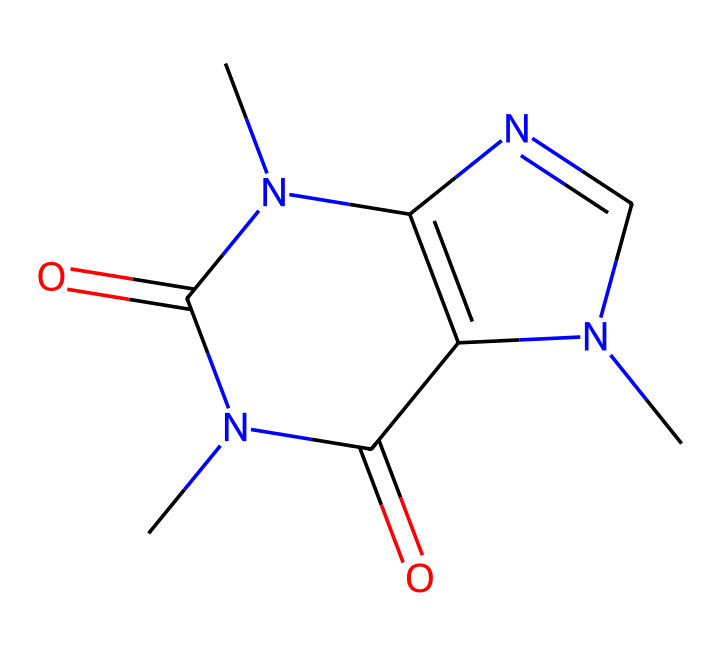What is the molecular formula of caffeine? To determine the molecular formula from the SMILES representation, we need to identify the components represented by the atoms. The SMILES shows carbon (C), nitrogen (N), and oxygen (O) atoms. Upon analyzing, we find there are 8 carbon atoms, 10 hydrogen atoms, 4 nitrogen atoms, and 2 oxygen atoms. Thus, the molecular formula derived is C8H10N4O2.
Answer: C8H10N4O2 How many nitrogen atoms are present in caffeine? By examining the SMILES notation, we can count the nitrogen atoms represented by the letter “N.” There are four occurrences of “N” in the structure. Therefore, there are four nitrogen atoms in caffeine.
Answer: 4 Is caffeine a heterocyclic compound? A heterocyclic compound contains a ring structure that includes at least one atom that is not carbon, commonly nitrogen, oxygen, or sulfur. The given SMILES indicates the presence of nitrogen atoms within a ring structure. This confirms that caffeine is indeed a heterocyclic compound.
Answer: Yes What types of bonds are present in caffeine? In the SMILES notation, there are single and double bonds indicated by specific symbols. The carbon-nitrogen (C-N) and carbon-carbon (C-C) connections are primarily single bonds, while the carbon-oxygen (C=O) connections indicate double bonds. Hence, caffeine has both single and double bonds.
Answer: single and double Which functional group is prominently featured in caffeine? Analyzing the structural components in caffeine, we see a carbonyl group (C=O) which classifies it as an amide, since it is connected to nitrogen atoms indicating amide functionalities. Therefore, the functional group prominently featured is the amide group.
Answer: amide 